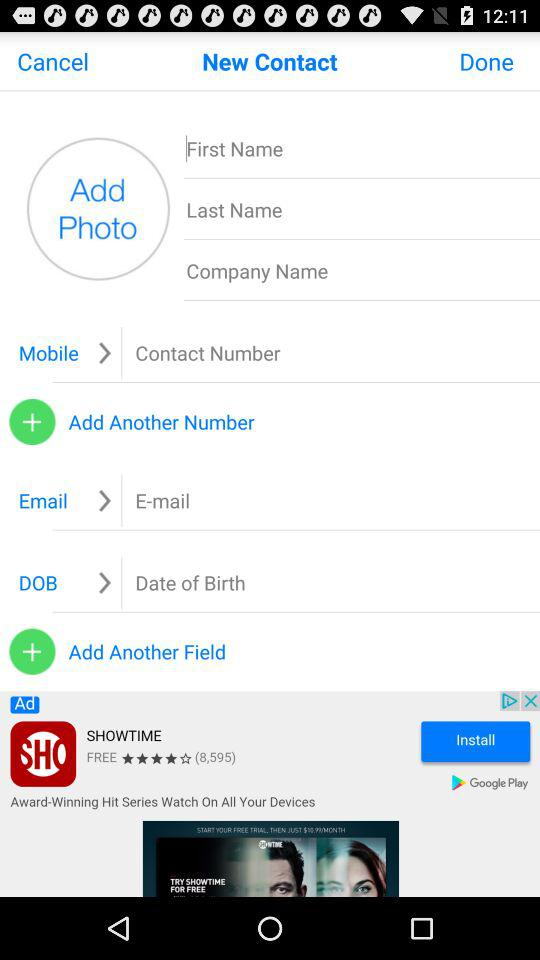What is the duration of the call? The duration of the call is 0 seconds. 